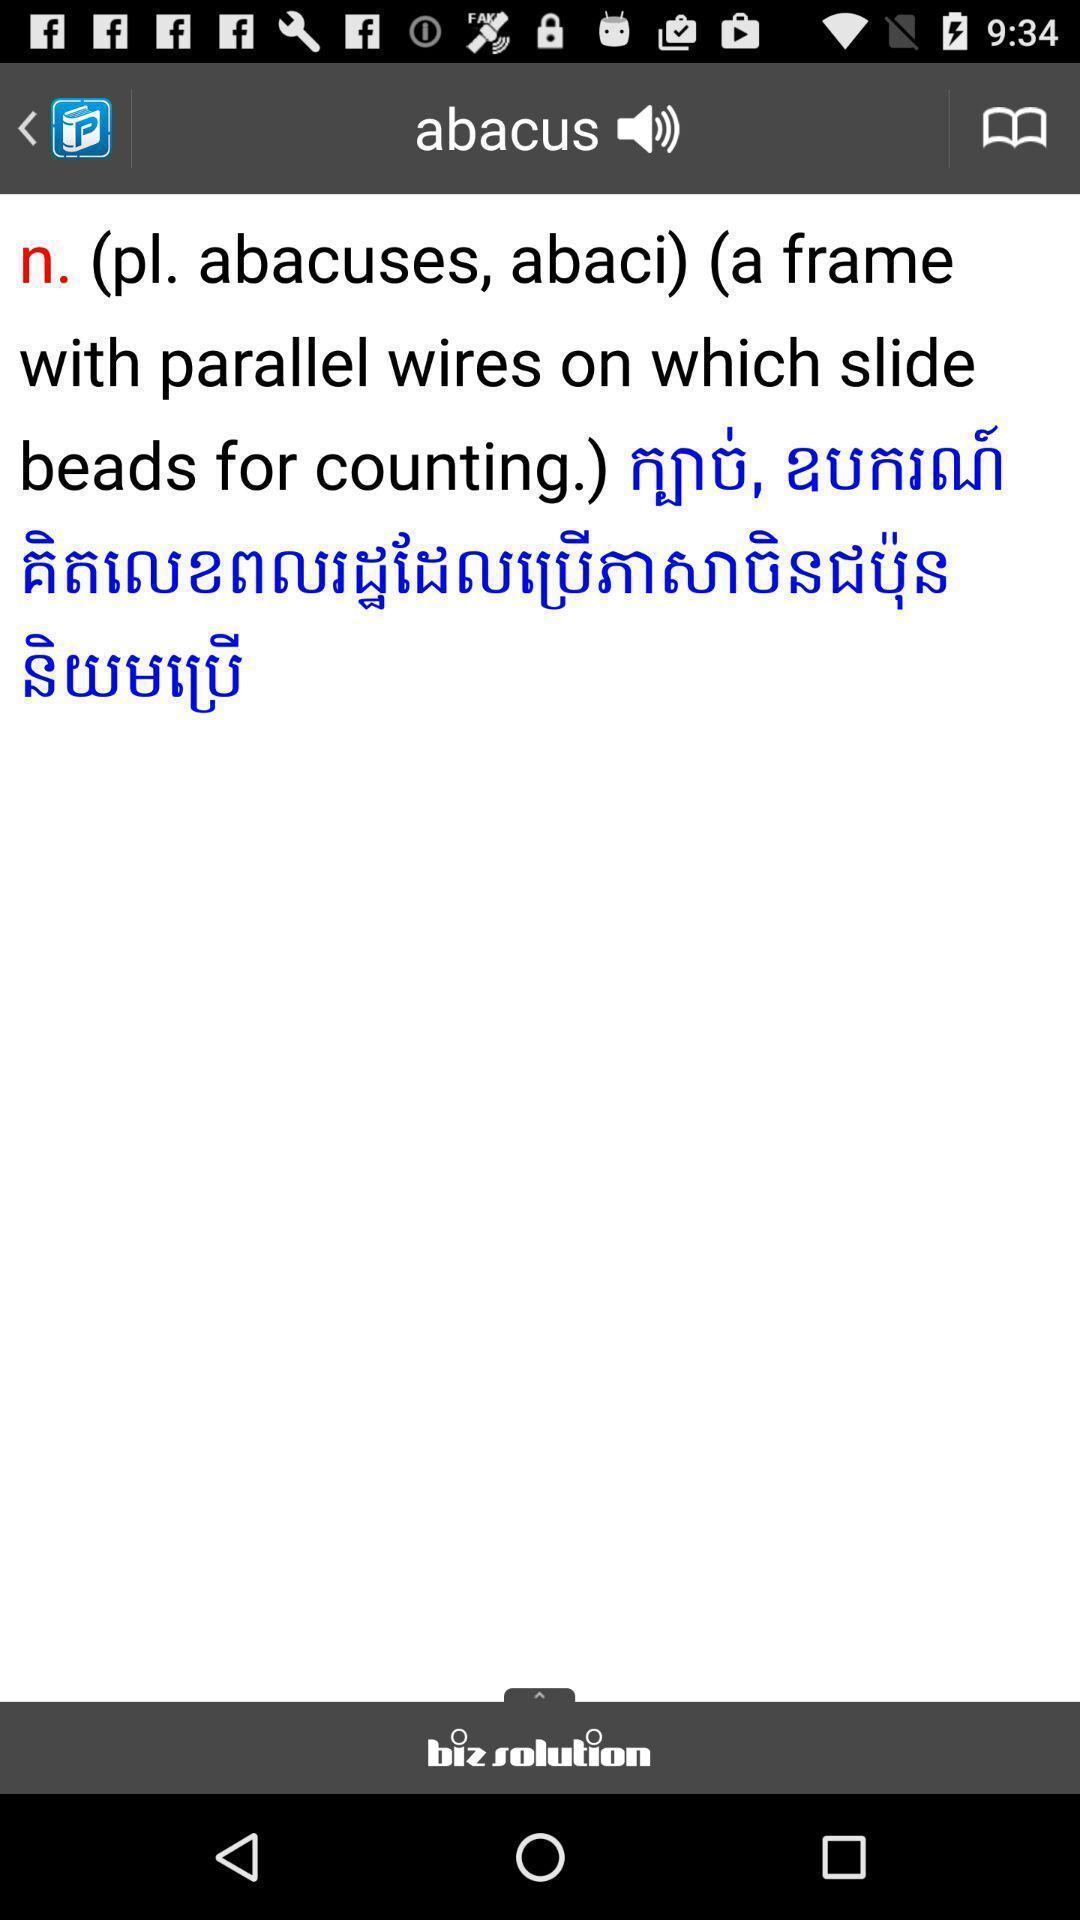Explain the elements present in this screenshot. Page showing information about abacus. 